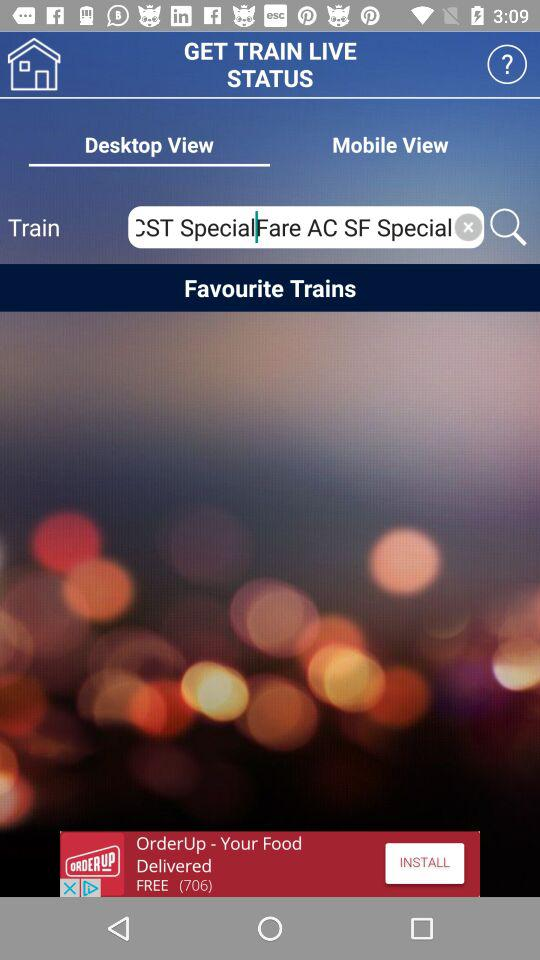Which tab is selected? The selected tab is "Desktop View". 